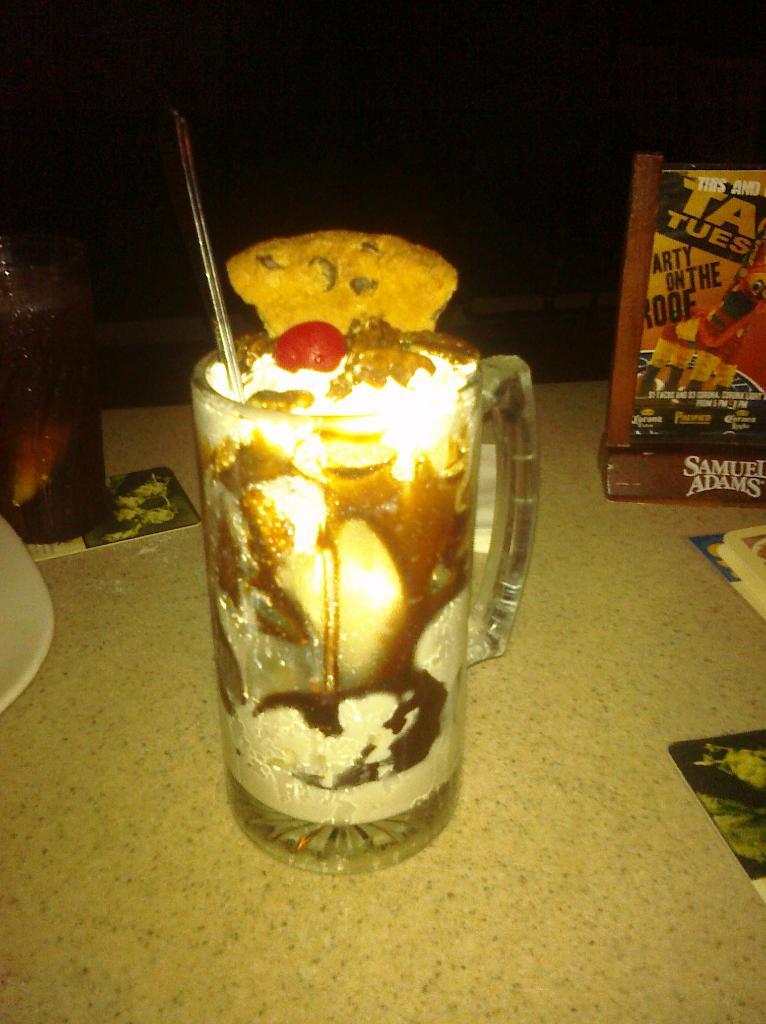Does that ad holder say samuel adams on the bottom?
Your response must be concise. Yes. 